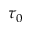Convert formula to latex. <formula><loc_0><loc_0><loc_500><loc_500>\tau _ { 0 }</formula> 